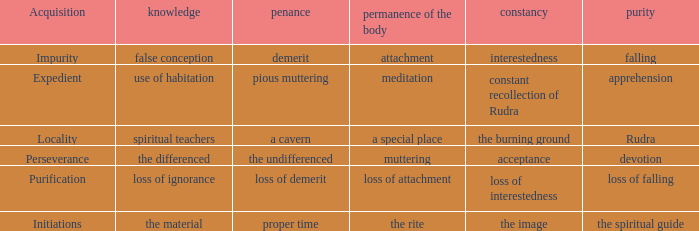 what's the permanence of the body where penance is the undifferenced Muttering. 